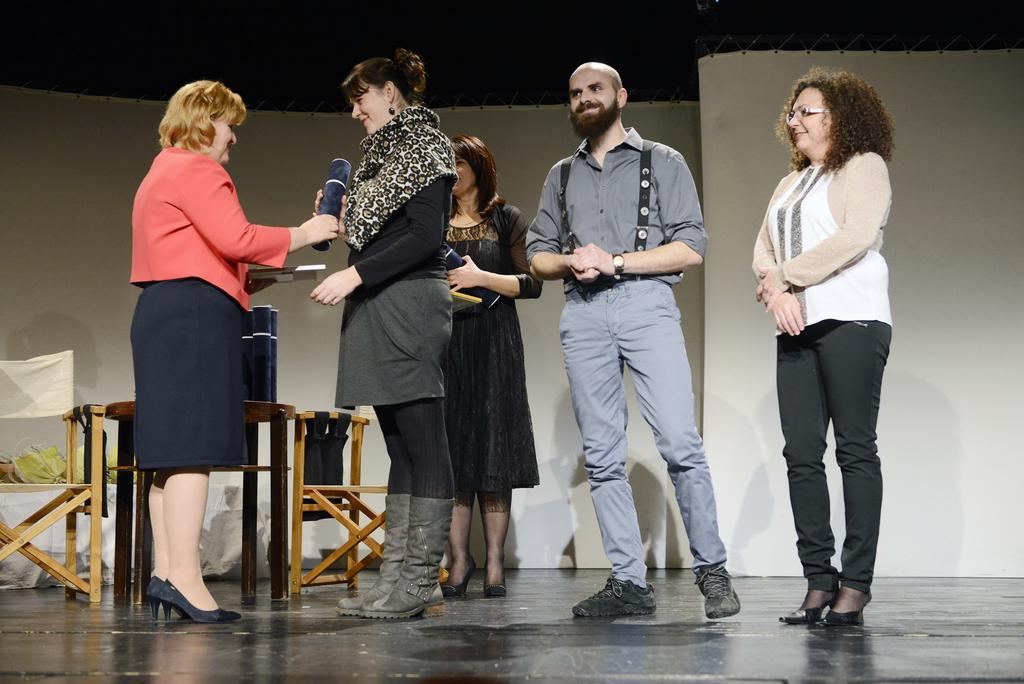What is happening on the stage in the image? There are people standing on a stage in the image, and one woman is giving an honor to another woman. What can be seen behind the people on the stage? There is a wall visible at the back of the stage. How many babies are playing baseball on the stage in the image? There are no babies or baseball activity present in the image. 